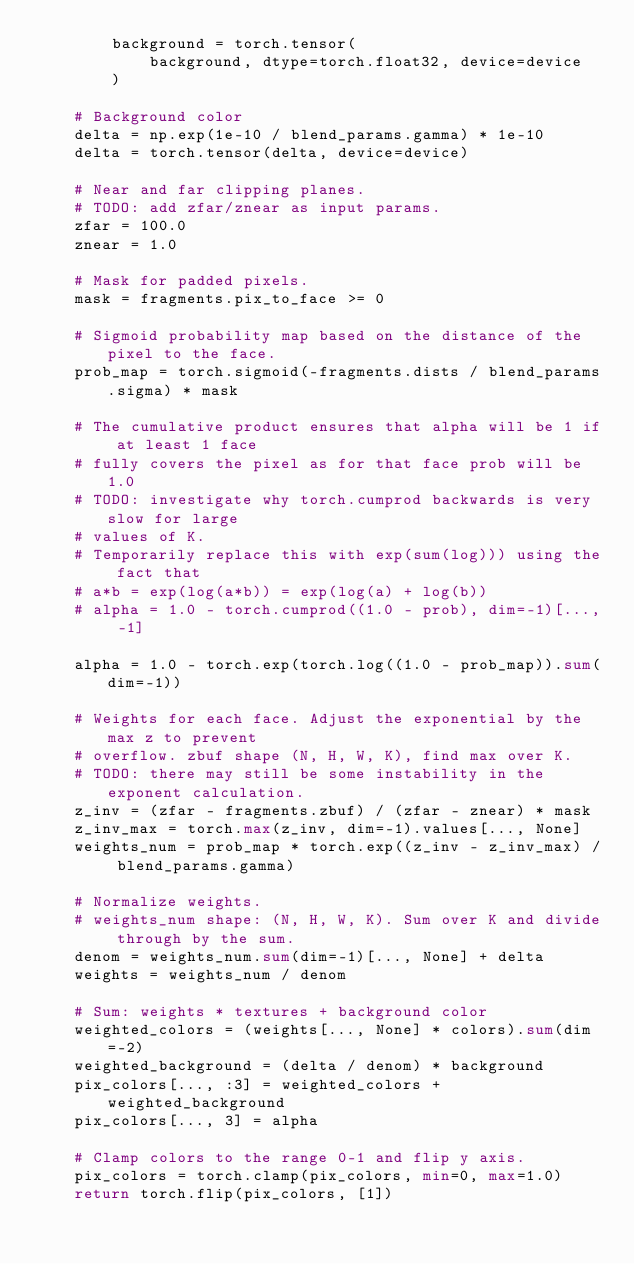<code> <loc_0><loc_0><loc_500><loc_500><_Python_>        background = torch.tensor(
            background, dtype=torch.float32, device=device
        )

    # Background color
    delta = np.exp(1e-10 / blend_params.gamma) * 1e-10
    delta = torch.tensor(delta, device=device)

    # Near and far clipping planes.
    # TODO: add zfar/znear as input params.
    zfar = 100.0
    znear = 1.0

    # Mask for padded pixels.
    mask = fragments.pix_to_face >= 0

    # Sigmoid probability map based on the distance of the pixel to the face.
    prob_map = torch.sigmoid(-fragments.dists / blend_params.sigma) * mask

    # The cumulative product ensures that alpha will be 1 if at least 1 face
    # fully covers the pixel as for that face prob will be 1.0
    # TODO: investigate why torch.cumprod backwards is very slow for large
    # values of K.
    # Temporarily replace this with exp(sum(log))) using the fact that
    # a*b = exp(log(a*b)) = exp(log(a) + log(b))
    # alpha = 1.0 - torch.cumprod((1.0 - prob), dim=-1)[..., -1]

    alpha = 1.0 - torch.exp(torch.log((1.0 - prob_map)).sum(dim=-1))

    # Weights for each face. Adjust the exponential by the max z to prevent
    # overflow. zbuf shape (N, H, W, K), find max over K.
    # TODO: there may still be some instability in the exponent calculation.
    z_inv = (zfar - fragments.zbuf) / (zfar - znear) * mask
    z_inv_max = torch.max(z_inv, dim=-1).values[..., None]
    weights_num = prob_map * torch.exp((z_inv - z_inv_max) / blend_params.gamma)

    # Normalize weights.
    # weights_num shape: (N, H, W, K). Sum over K and divide through by the sum.
    denom = weights_num.sum(dim=-1)[..., None] + delta
    weights = weights_num / denom

    # Sum: weights * textures + background color
    weighted_colors = (weights[..., None] * colors).sum(dim=-2)
    weighted_background = (delta / denom) * background
    pix_colors[..., :3] = weighted_colors + weighted_background
    pix_colors[..., 3] = alpha

    # Clamp colors to the range 0-1 and flip y axis.
    pix_colors = torch.clamp(pix_colors, min=0, max=1.0)
    return torch.flip(pix_colors, [1])
</code> 